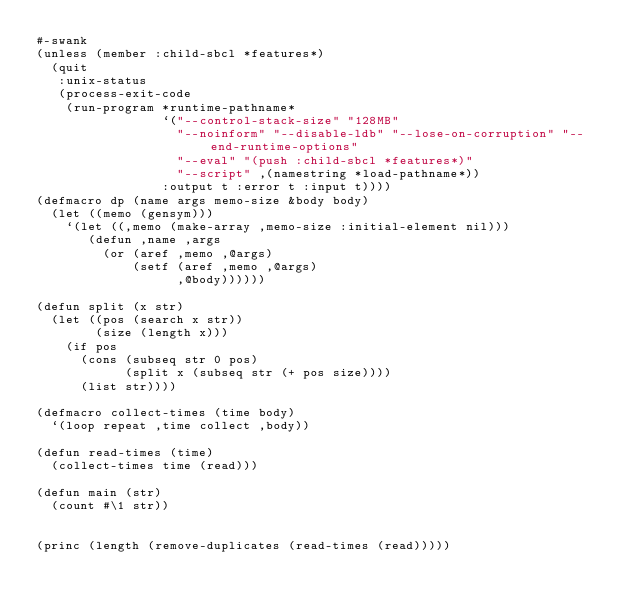<code> <loc_0><loc_0><loc_500><loc_500><_Lisp_>#-swank
(unless (member :child-sbcl *features*)
  (quit
   :unix-status
   (process-exit-code
    (run-program *runtime-pathname*
                 `("--control-stack-size" "128MB"
                   "--noinform" "--disable-ldb" "--lose-on-corruption" "--end-runtime-options"
                   "--eval" "(push :child-sbcl *features*)"
                   "--script" ,(namestring *load-pathname*))
                 :output t :error t :input t))))
(defmacro dp (name args memo-size &body body)
  (let ((memo (gensym)))
    `(let ((,memo (make-array ,memo-size :initial-element nil)))
       (defun ,name ,args
         (or (aref ,memo ,@args)
             (setf (aref ,memo ,@args)
                   ,@body))))))

(defun split (x str)
  (let ((pos (search x str))
        (size (length x)))
    (if pos
      (cons (subseq str 0 pos)
            (split x (subseq str (+ pos size))))
      (list str))))

(defmacro collect-times (time body)
  `(loop repeat ,time collect ,body))

(defun read-times (time)
  (collect-times time (read)))

(defun main (str)
  (count #\1 str))


(princ (length (remove-duplicates (read-times (read)))))
</code> 